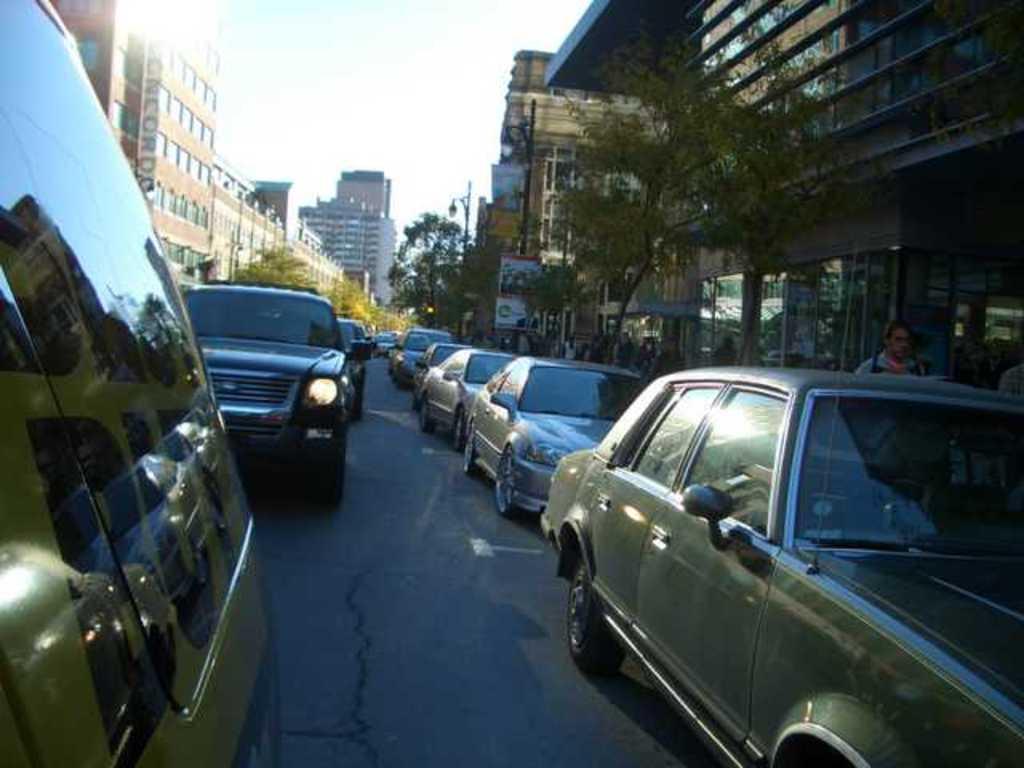Could you give a brief overview of what you see in this image? In the image there are cars on either side of the road and there are buildings behind it with trees in front of them and above its sky. 